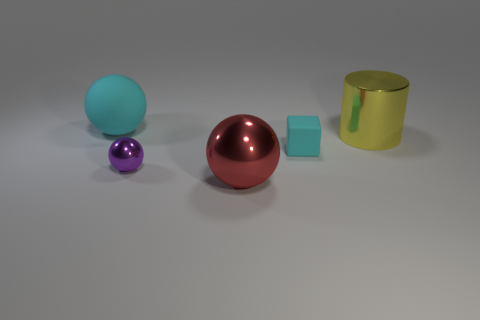Is there any other thing that is the same size as the yellow metallic cylinder? Upon observation of the image, it appears that none of the objects share the exact dimensions as the yellow metallic cylinder. Each object has unique size traits, making them distinct in size. 